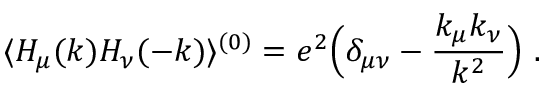<formula> <loc_0><loc_0><loc_500><loc_500>\langle H _ { \mu } ( k ) H _ { \nu } ( - k ) \rangle ^ { ( 0 ) } = e ^ { 2 } \left ( \delta _ { \mu \nu } - { \frac { k _ { \mu } k _ { \nu } } { k ^ { 2 } } } \right ) \ .</formula> 